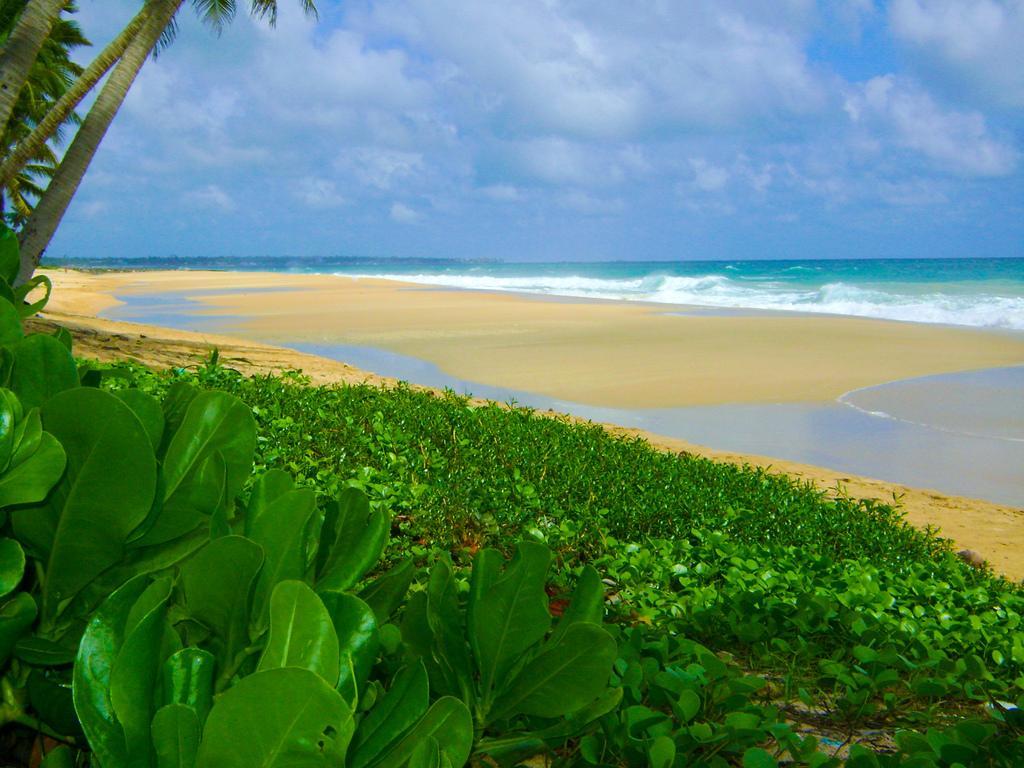Can you describe this image briefly? In the image in the center we can see plants,grass and trees. In the background we can see the sky,clouds and water. 